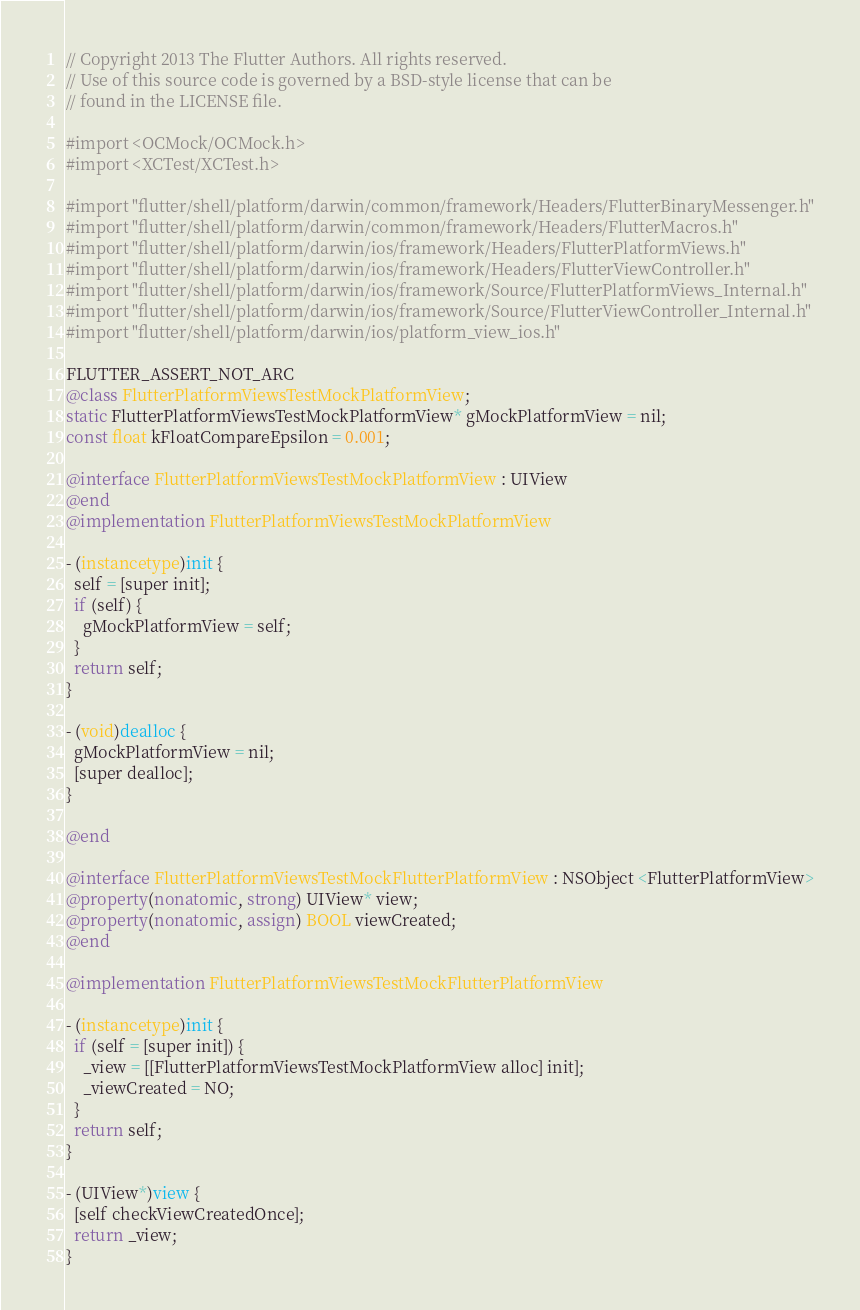Convert code to text. <code><loc_0><loc_0><loc_500><loc_500><_ObjectiveC_>// Copyright 2013 The Flutter Authors. All rights reserved.
// Use of this source code is governed by a BSD-style license that can be
// found in the LICENSE file.

#import <OCMock/OCMock.h>
#import <XCTest/XCTest.h>

#import "flutter/shell/platform/darwin/common/framework/Headers/FlutterBinaryMessenger.h"
#import "flutter/shell/platform/darwin/common/framework/Headers/FlutterMacros.h"
#import "flutter/shell/platform/darwin/ios/framework/Headers/FlutterPlatformViews.h"
#import "flutter/shell/platform/darwin/ios/framework/Headers/FlutterViewController.h"
#import "flutter/shell/platform/darwin/ios/framework/Source/FlutterPlatformViews_Internal.h"
#import "flutter/shell/platform/darwin/ios/framework/Source/FlutterViewController_Internal.h"
#import "flutter/shell/platform/darwin/ios/platform_view_ios.h"

FLUTTER_ASSERT_NOT_ARC
@class FlutterPlatformViewsTestMockPlatformView;
static FlutterPlatformViewsTestMockPlatformView* gMockPlatformView = nil;
const float kFloatCompareEpsilon = 0.001;

@interface FlutterPlatformViewsTestMockPlatformView : UIView
@end
@implementation FlutterPlatformViewsTestMockPlatformView

- (instancetype)init {
  self = [super init];
  if (self) {
    gMockPlatformView = self;
  }
  return self;
}

- (void)dealloc {
  gMockPlatformView = nil;
  [super dealloc];
}

@end

@interface FlutterPlatformViewsTestMockFlutterPlatformView : NSObject <FlutterPlatformView>
@property(nonatomic, strong) UIView* view;
@property(nonatomic, assign) BOOL viewCreated;
@end

@implementation FlutterPlatformViewsTestMockFlutterPlatformView

- (instancetype)init {
  if (self = [super init]) {
    _view = [[FlutterPlatformViewsTestMockPlatformView alloc] init];
    _viewCreated = NO;
  }
  return self;
}

- (UIView*)view {
  [self checkViewCreatedOnce];
  return _view;
}
</code> 